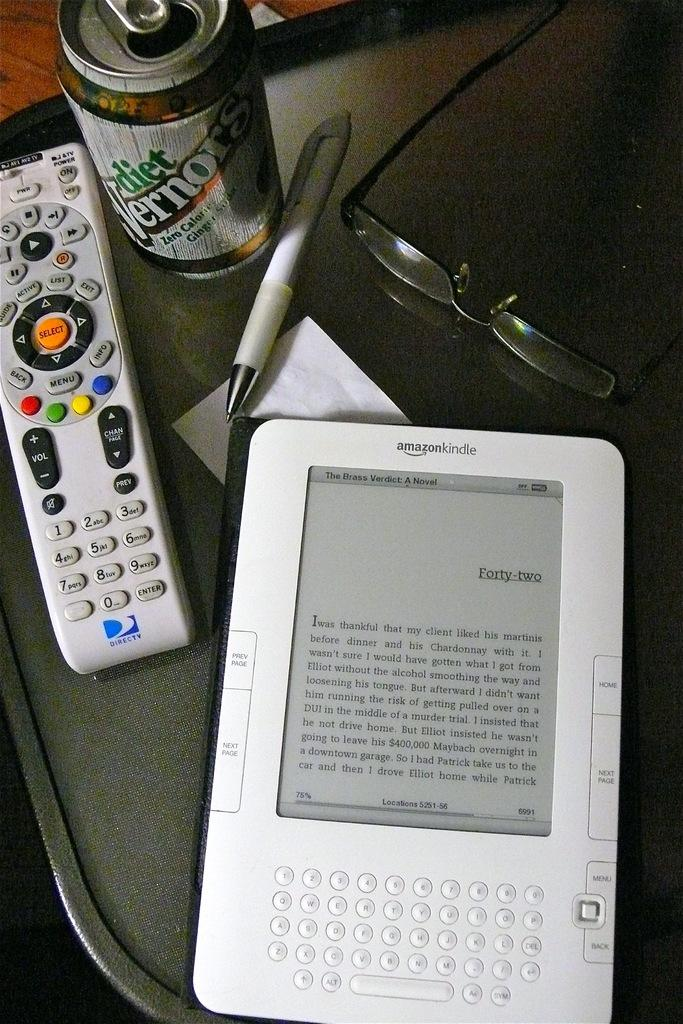<image>
Write a terse but informative summary of the picture. A can of Diet Vernon next to a remote control and a Kindle. 